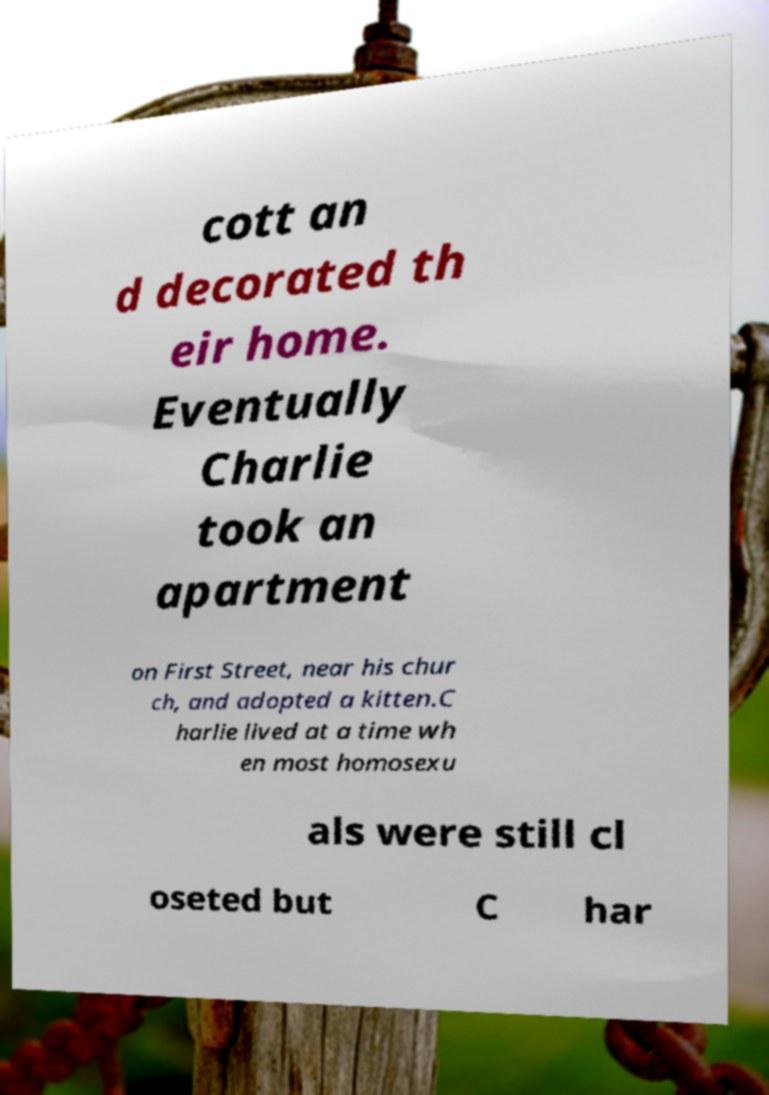Please identify and transcribe the text found in this image. cott an d decorated th eir home. Eventually Charlie took an apartment on First Street, near his chur ch, and adopted a kitten.C harlie lived at a time wh en most homosexu als were still cl oseted but C har 